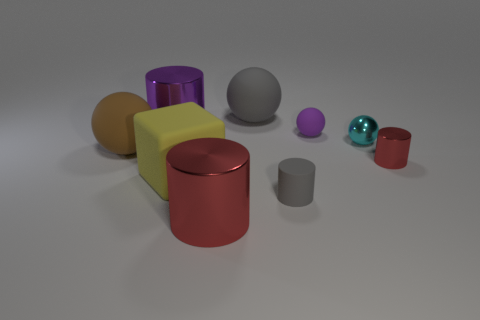How do the colors of the objects in the image relate to their sizes? The colors of the objects in the image don't have a consistent relationship with their sizes. For instance, we see both large and small objects in various colors, like the larger yellow cube and the smaller red cylinder. Color seems to be an independent attribute from size in this case. 